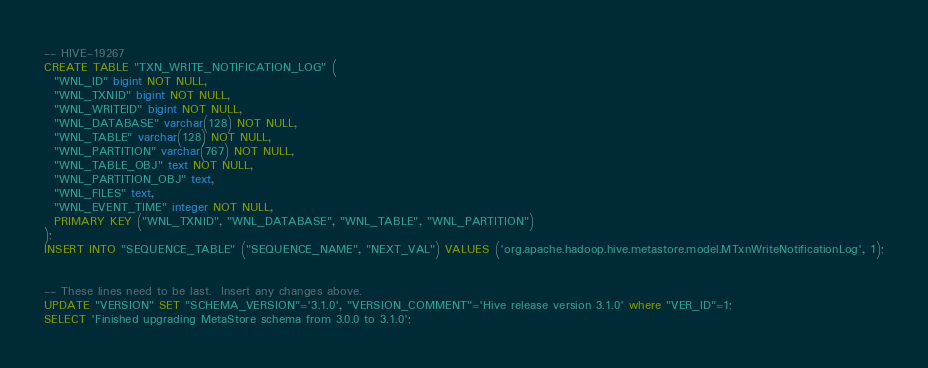Convert code to text. <code><loc_0><loc_0><loc_500><loc_500><_SQL_>-- HIVE-19267
CREATE TABLE "TXN_WRITE_NOTIFICATION_LOG" (
  "WNL_ID" bigint NOT NULL,
  "WNL_TXNID" bigint NOT NULL,
  "WNL_WRITEID" bigint NOT NULL,
  "WNL_DATABASE" varchar(128) NOT NULL,
  "WNL_TABLE" varchar(128) NOT NULL,
  "WNL_PARTITION" varchar(767) NOT NULL,
  "WNL_TABLE_OBJ" text NOT NULL,
  "WNL_PARTITION_OBJ" text,
  "WNL_FILES" text,
  "WNL_EVENT_TIME" integer NOT NULL,
  PRIMARY KEY ("WNL_TXNID", "WNL_DATABASE", "WNL_TABLE", "WNL_PARTITION")
);
INSERT INTO "SEQUENCE_TABLE" ("SEQUENCE_NAME", "NEXT_VAL") VALUES ('org.apache.hadoop.hive.metastore.model.MTxnWriteNotificationLog', 1);


-- These lines need to be last.  Insert any changes above.
UPDATE "VERSION" SET "SCHEMA_VERSION"='3.1.0', "VERSION_COMMENT"='Hive release version 3.1.0' where "VER_ID"=1;
SELECT 'Finished upgrading MetaStore schema from 3.0.0 to 3.1.0';
</code> 